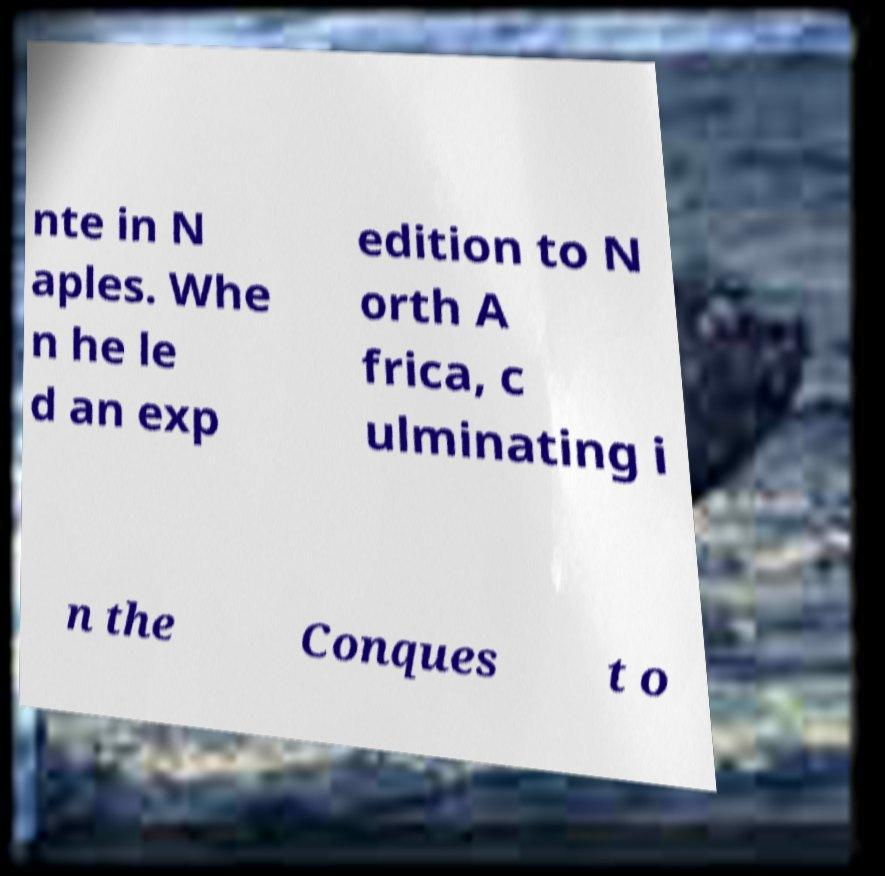Could you assist in decoding the text presented in this image and type it out clearly? nte in N aples. Whe n he le d an exp edition to N orth A frica, c ulminating i n the Conques t o 